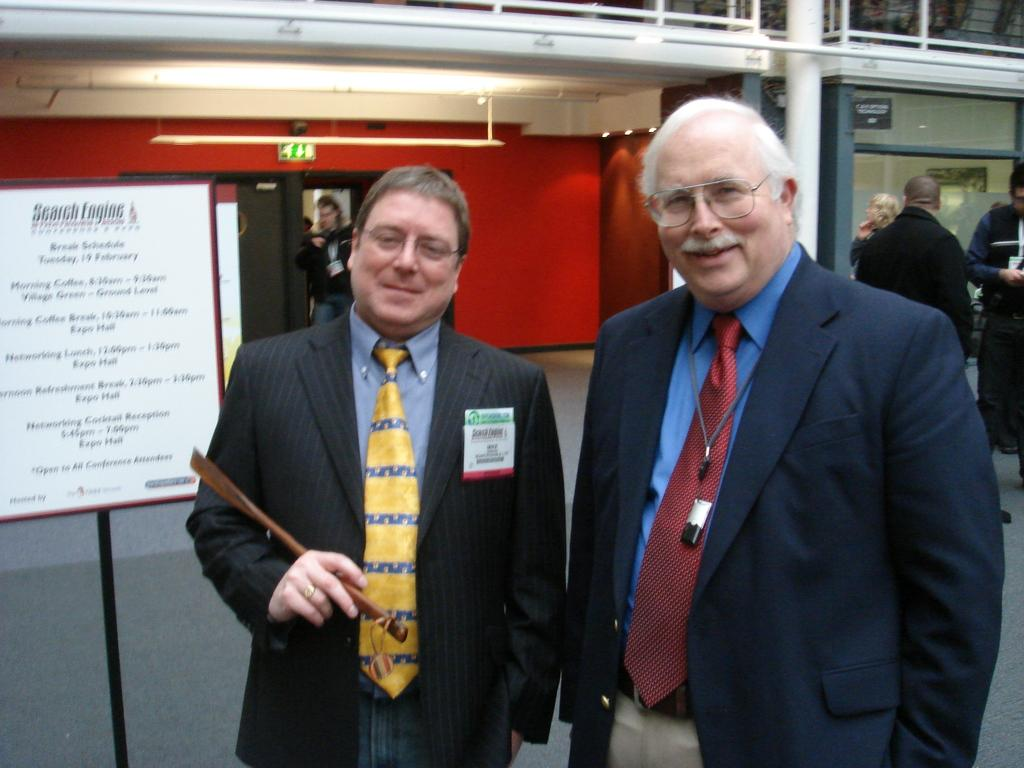Where was the image taken? The image was clicked outside. What can be seen on the left side of the image? There is a board on the left side of the image. How many people are in the image? There are two persons in the middle of the image. What are the persons wearing? The persons are wearing blazers and ties. What is visible at the top of the image? There is light visible at the top of the image. Can you see any boats in the image? No, there are no boats visible in the image. 